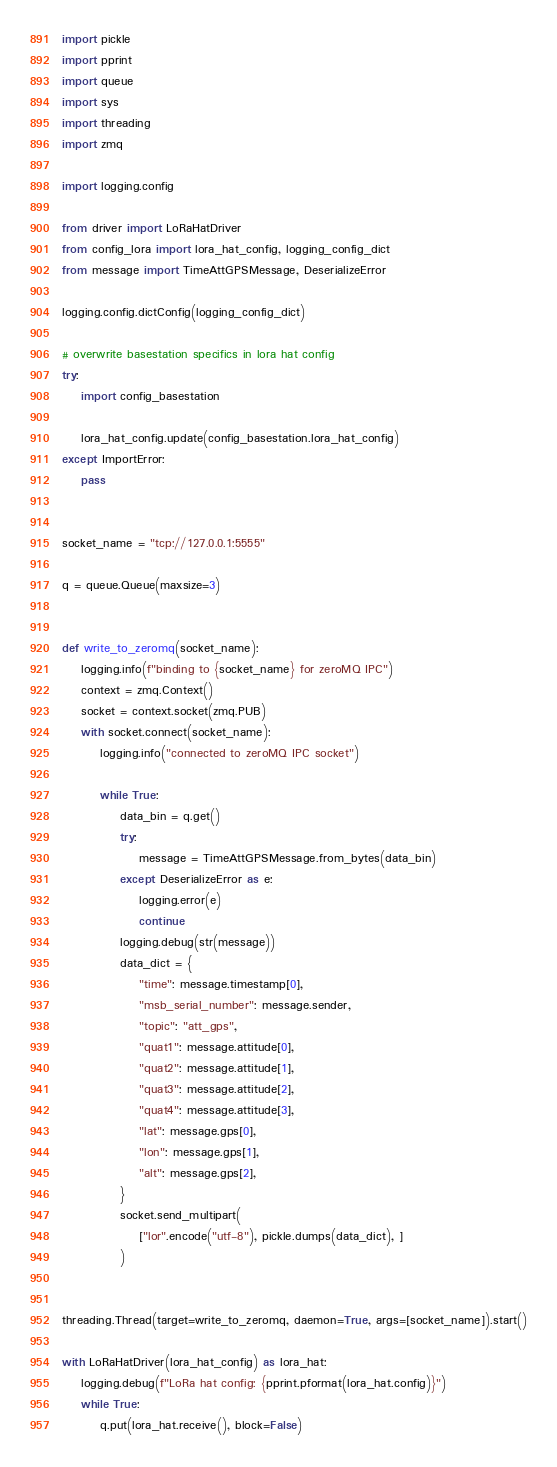<code> <loc_0><loc_0><loc_500><loc_500><_Python_>import pickle
import pprint
import queue
import sys
import threading
import zmq

import logging.config

from driver import LoRaHatDriver
from config_lora import lora_hat_config, logging_config_dict
from message import TimeAttGPSMessage, DeserializeError

logging.config.dictConfig(logging_config_dict)

# overwrite basestation specifics in lora hat config
try:
    import config_basestation

    lora_hat_config.update(config_basestation.lora_hat_config)
except ImportError:
    pass


socket_name = "tcp://127.0.0.1:5555"

q = queue.Queue(maxsize=3)


def write_to_zeromq(socket_name):
    logging.info(f"binding to {socket_name} for zeroMQ IPC")
    context = zmq.Context()
    socket = context.socket(zmq.PUB)
    with socket.connect(socket_name):
        logging.info("connected to zeroMQ IPC socket")

        while True:
            data_bin = q.get()
            try:
                message = TimeAttGPSMessage.from_bytes(data_bin)
            except DeserializeError as e:
                logging.error(e)
                continue
            logging.debug(str(message))
            data_dict = {
                "time": message.timestamp[0],
                "msb_serial_number": message.sender,
                "topic": "att_gps",
                "quat1": message.attitude[0],
                "quat2": message.attitude[1],
                "quat3": message.attitude[2],
                "quat4": message.attitude[3],
                "lat": message.gps[0],
                "lon": message.gps[1],
                "alt": message.gps[2],
            }
            socket.send_multipart(
                ["lor".encode("utf-8"), pickle.dumps(data_dict), ]
            )


threading.Thread(target=write_to_zeromq, daemon=True, args=[socket_name]).start()

with LoRaHatDriver(lora_hat_config) as lora_hat:
    logging.debug(f"LoRa hat config: {pprint.pformat(lora_hat.config)}")
    while True:
        q.put(lora_hat.receive(), block=False)
</code> 